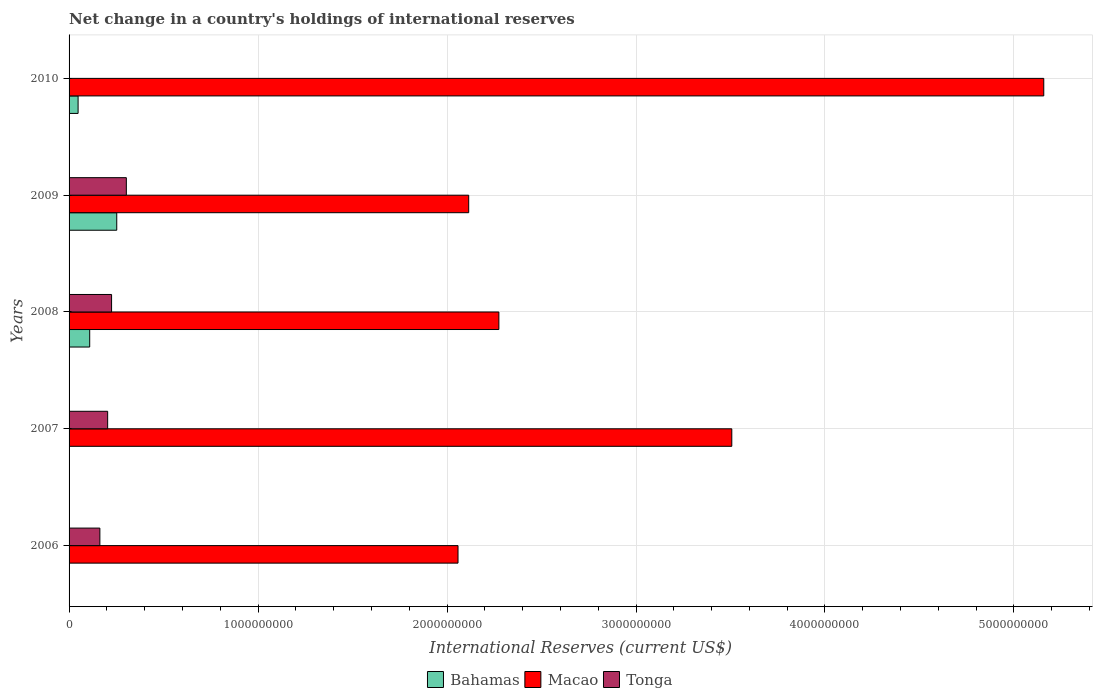How many groups of bars are there?
Provide a succinct answer. 5. Are the number of bars per tick equal to the number of legend labels?
Your response must be concise. No. Are the number of bars on each tick of the Y-axis equal?
Offer a very short reply. No. How many bars are there on the 4th tick from the top?
Offer a very short reply. 2. What is the label of the 5th group of bars from the top?
Your answer should be very brief. 2006. Across all years, what is the maximum international reserves in Macao?
Offer a very short reply. 5.16e+09. Across all years, what is the minimum international reserves in Tonga?
Your answer should be very brief. 0. In which year was the international reserves in Bahamas maximum?
Provide a succinct answer. 2009. What is the total international reserves in Macao in the graph?
Offer a very short reply. 1.51e+1. What is the difference between the international reserves in Tonga in 2006 and that in 2008?
Keep it short and to the point. -6.19e+07. What is the difference between the international reserves in Macao in 2010 and the international reserves in Bahamas in 2008?
Keep it short and to the point. 5.05e+09. What is the average international reserves in Bahamas per year?
Offer a terse response. 8.18e+07. In the year 2008, what is the difference between the international reserves in Bahamas and international reserves in Macao?
Provide a short and direct response. -2.17e+09. What is the ratio of the international reserves in Macao in 2006 to that in 2008?
Offer a terse response. 0.9. Is the difference between the international reserves in Bahamas in 2009 and 2010 greater than the difference between the international reserves in Macao in 2009 and 2010?
Offer a terse response. Yes. What is the difference between the highest and the second highest international reserves in Macao?
Keep it short and to the point. 1.65e+09. What is the difference between the highest and the lowest international reserves in Macao?
Offer a terse response. 3.10e+09. In how many years, is the international reserves in Macao greater than the average international reserves in Macao taken over all years?
Your response must be concise. 2. Are the values on the major ticks of X-axis written in scientific E-notation?
Keep it short and to the point. No. Does the graph contain any zero values?
Your response must be concise. Yes. Where does the legend appear in the graph?
Ensure brevity in your answer.  Bottom center. How many legend labels are there?
Your response must be concise. 3. What is the title of the graph?
Your response must be concise. Net change in a country's holdings of international reserves. What is the label or title of the X-axis?
Ensure brevity in your answer.  International Reserves (current US$). What is the International Reserves (current US$) of Macao in 2006?
Ensure brevity in your answer.  2.06e+09. What is the International Reserves (current US$) of Tonga in 2006?
Provide a short and direct response. 1.63e+08. What is the International Reserves (current US$) of Macao in 2007?
Ensure brevity in your answer.  3.51e+09. What is the International Reserves (current US$) of Tonga in 2007?
Ensure brevity in your answer.  2.04e+08. What is the International Reserves (current US$) in Bahamas in 2008?
Provide a short and direct response. 1.09e+08. What is the International Reserves (current US$) in Macao in 2008?
Keep it short and to the point. 2.27e+09. What is the International Reserves (current US$) in Tonga in 2008?
Offer a terse response. 2.25e+08. What is the International Reserves (current US$) in Bahamas in 2009?
Provide a succinct answer. 2.52e+08. What is the International Reserves (current US$) of Macao in 2009?
Keep it short and to the point. 2.11e+09. What is the International Reserves (current US$) of Tonga in 2009?
Make the answer very short. 3.03e+08. What is the International Reserves (current US$) in Bahamas in 2010?
Provide a succinct answer. 4.78e+07. What is the International Reserves (current US$) of Macao in 2010?
Your answer should be compact. 5.16e+09. Across all years, what is the maximum International Reserves (current US$) in Bahamas?
Provide a short and direct response. 2.52e+08. Across all years, what is the maximum International Reserves (current US$) of Macao?
Offer a terse response. 5.16e+09. Across all years, what is the maximum International Reserves (current US$) in Tonga?
Ensure brevity in your answer.  3.03e+08. Across all years, what is the minimum International Reserves (current US$) in Bahamas?
Provide a succinct answer. 0. Across all years, what is the minimum International Reserves (current US$) of Macao?
Ensure brevity in your answer.  2.06e+09. Across all years, what is the minimum International Reserves (current US$) in Tonga?
Offer a very short reply. 0. What is the total International Reserves (current US$) in Bahamas in the graph?
Offer a very short reply. 4.09e+08. What is the total International Reserves (current US$) in Macao in the graph?
Offer a very short reply. 1.51e+1. What is the total International Reserves (current US$) in Tonga in the graph?
Make the answer very short. 8.95e+08. What is the difference between the International Reserves (current US$) of Macao in 2006 and that in 2007?
Make the answer very short. -1.45e+09. What is the difference between the International Reserves (current US$) in Tonga in 2006 and that in 2007?
Provide a short and direct response. -4.11e+07. What is the difference between the International Reserves (current US$) of Macao in 2006 and that in 2008?
Offer a very short reply. -2.16e+08. What is the difference between the International Reserves (current US$) of Tonga in 2006 and that in 2008?
Ensure brevity in your answer.  -6.19e+07. What is the difference between the International Reserves (current US$) in Macao in 2006 and that in 2009?
Your answer should be compact. -5.65e+07. What is the difference between the International Reserves (current US$) of Tonga in 2006 and that in 2009?
Provide a short and direct response. -1.40e+08. What is the difference between the International Reserves (current US$) of Macao in 2006 and that in 2010?
Provide a succinct answer. -3.10e+09. What is the difference between the International Reserves (current US$) in Macao in 2007 and that in 2008?
Provide a succinct answer. 1.23e+09. What is the difference between the International Reserves (current US$) in Tonga in 2007 and that in 2008?
Provide a succinct answer. -2.07e+07. What is the difference between the International Reserves (current US$) in Macao in 2007 and that in 2009?
Ensure brevity in your answer.  1.39e+09. What is the difference between the International Reserves (current US$) of Tonga in 2007 and that in 2009?
Offer a very short reply. -9.89e+07. What is the difference between the International Reserves (current US$) of Macao in 2007 and that in 2010?
Provide a succinct answer. -1.65e+09. What is the difference between the International Reserves (current US$) in Bahamas in 2008 and that in 2009?
Make the answer very short. -1.43e+08. What is the difference between the International Reserves (current US$) in Macao in 2008 and that in 2009?
Make the answer very short. 1.60e+08. What is the difference between the International Reserves (current US$) in Tonga in 2008 and that in 2009?
Offer a very short reply. -7.81e+07. What is the difference between the International Reserves (current US$) in Bahamas in 2008 and that in 2010?
Your response must be concise. 6.15e+07. What is the difference between the International Reserves (current US$) of Macao in 2008 and that in 2010?
Offer a very short reply. -2.88e+09. What is the difference between the International Reserves (current US$) of Bahamas in 2009 and that in 2010?
Your response must be concise. 2.05e+08. What is the difference between the International Reserves (current US$) of Macao in 2009 and that in 2010?
Offer a very short reply. -3.04e+09. What is the difference between the International Reserves (current US$) of Macao in 2006 and the International Reserves (current US$) of Tonga in 2007?
Make the answer very short. 1.85e+09. What is the difference between the International Reserves (current US$) of Macao in 2006 and the International Reserves (current US$) of Tonga in 2008?
Ensure brevity in your answer.  1.83e+09. What is the difference between the International Reserves (current US$) of Macao in 2006 and the International Reserves (current US$) of Tonga in 2009?
Offer a very short reply. 1.76e+09. What is the difference between the International Reserves (current US$) of Macao in 2007 and the International Reserves (current US$) of Tonga in 2008?
Make the answer very short. 3.28e+09. What is the difference between the International Reserves (current US$) in Macao in 2007 and the International Reserves (current US$) in Tonga in 2009?
Your answer should be compact. 3.20e+09. What is the difference between the International Reserves (current US$) of Bahamas in 2008 and the International Reserves (current US$) of Macao in 2009?
Give a very brief answer. -2.01e+09. What is the difference between the International Reserves (current US$) of Bahamas in 2008 and the International Reserves (current US$) of Tonga in 2009?
Make the answer very short. -1.94e+08. What is the difference between the International Reserves (current US$) in Macao in 2008 and the International Reserves (current US$) in Tonga in 2009?
Ensure brevity in your answer.  1.97e+09. What is the difference between the International Reserves (current US$) of Bahamas in 2008 and the International Reserves (current US$) of Macao in 2010?
Give a very brief answer. -5.05e+09. What is the difference between the International Reserves (current US$) in Bahamas in 2009 and the International Reserves (current US$) in Macao in 2010?
Offer a terse response. -4.91e+09. What is the average International Reserves (current US$) of Bahamas per year?
Make the answer very short. 8.18e+07. What is the average International Reserves (current US$) of Macao per year?
Your answer should be very brief. 3.02e+09. What is the average International Reserves (current US$) in Tonga per year?
Your answer should be very brief. 1.79e+08. In the year 2006, what is the difference between the International Reserves (current US$) in Macao and International Reserves (current US$) in Tonga?
Provide a succinct answer. 1.90e+09. In the year 2007, what is the difference between the International Reserves (current US$) in Macao and International Reserves (current US$) in Tonga?
Offer a very short reply. 3.30e+09. In the year 2008, what is the difference between the International Reserves (current US$) of Bahamas and International Reserves (current US$) of Macao?
Provide a succinct answer. -2.17e+09. In the year 2008, what is the difference between the International Reserves (current US$) in Bahamas and International Reserves (current US$) in Tonga?
Provide a short and direct response. -1.16e+08. In the year 2008, what is the difference between the International Reserves (current US$) in Macao and International Reserves (current US$) in Tonga?
Your response must be concise. 2.05e+09. In the year 2009, what is the difference between the International Reserves (current US$) in Bahamas and International Reserves (current US$) in Macao?
Your answer should be very brief. -1.86e+09. In the year 2009, what is the difference between the International Reserves (current US$) of Bahamas and International Reserves (current US$) of Tonga?
Offer a very short reply. -5.08e+07. In the year 2009, what is the difference between the International Reserves (current US$) in Macao and International Reserves (current US$) in Tonga?
Your answer should be compact. 1.81e+09. In the year 2010, what is the difference between the International Reserves (current US$) of Bahamas and International Reserves (current US$) of Macao?
Ensure brevity in your answer.  -5.11e+09. What is the ratio of the International Reserves (current US$) in Macao in 2006 to that in 2007?
Provide a succinct answer. 0.59. What is the ratio of the International Reserves (current US$) in Tonga in 2006 to that in 2007?
Give a very brief answer. 0.8. What is the ratio of the International Reserves (current US$) in Macao in 2006 to that in 2008?
Keep it short and to the point. 0.9. What is the ratio of the International Reserves (current US$) of Tonga in 2006 to that in 2008?
Your answer should be very brief. 0.72. What is the ratio of the International Reserves (current US$) of Macao in 2006 to that in 2009?
Your answer should be very brief. 0.97. What is the ratio of the International Reserves (current US$) of Tonga in 2006 to that in 2009?
Ensure brevity in your answer.  0.54. What is the ratio of the International Reserves (current US$) in Macao in 2006 to that in 2010?
Provide a succinct answer. 0.4. What is the ratio of the International Reserves (current US$) in Macao in 2007 to that in 2008?
Offer a very short reply. 1.54. What is the ratio of the International Reserves (current US$) in Tonga in 2007 to that in 2008?
Your answer should be compact. 0.91. What is the ratio of the International Reserves (current US$) in Macao in 2007 to that in 2009?
Your answer should be compact. 1.66. What is the ratio of the International Reserves (current US$) of Tonga in 2007 to that in 2009?
Your answer should be very brief. 0.67. What is the ratio of the International Reserves (current US$) of Macao in 2007 to that in 2010?
Ensure brevity in your answer.  0.68. What is the ratio of the International Reserves (current US$) in Bahamas in 2008 to that in 2009?
Provide a succinct answer. 0.43. What is the ratio of the International Reserves (current US$) in Macao in 2008 to that in 2009?
Provide a succinct answer. 1.08. What is the ratio of the International Reserves (current US$) of Tonga in 2008 to that in 2009?
Your response must be concise. 0.74. What is the ratio of the International Reserves (current US$) in Bahamas in 2008 to that in 2010?
Offer a very short reply. 2.29. What is the ratio of the International Reserves (current US$) in Macao in 2008 to that in 2010?
Your answer should be very brief. 0.44. What is the ratio of the International Reserves (current US$) in Bahamas in 2009 to that in 2010?
Provide a succinct answer. 5.28. What is the ratio of the International Reserves (current US$) in Macao in 2009 to that in 2010?
Your answer should be compact. 0.41. What is the difference between the highest and the second highest International Reserves (current US$) of Bahamas?
Provide a succinct answer. 1.43e+08. What is the difference between the highest and the second highest International Reserves (current US$) of Macao?
Give a very brief answer. 1.65e+09. What is the difference between the highest and the second highest International Reserves (current US$) in Tonga?
Your answer should be compact. 7.81e+07. What is the difference between the highest and the lowest International Reserves (current US$) of Bahamas?
Provide a short and direct response. 2.52e+08. What is the difference between the highest and the lowest International Reserves (current US$) of Macao?
Give a very brief answer. 3.10e+09. What is the difference between the highest and the lowest International Reserves (current US$) in Tonga?
Keep it short and to the point. 3.03e+08. 